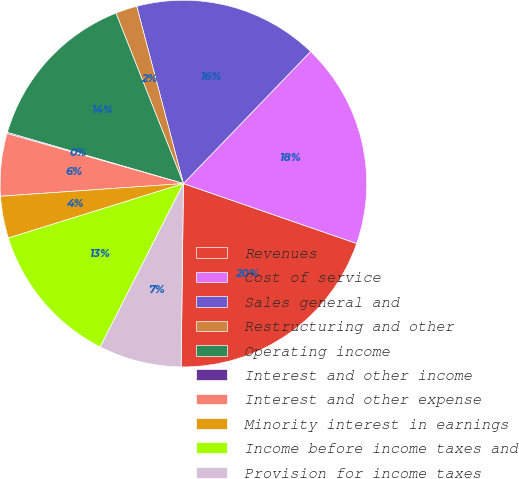<chart> <loc_0><loc_0><loc_500><loc_500><pie_chart><fcel>Revenues<fcel>Cost of service<fcel>Sales general and<fcel>Restructuring and other<fcel>Operating income<fcel>Interest and other income<fcel>Interest and other expense<fcel>Minority interest in earnings<fcel>Income before income taxes and<fcel>Provision for income taxes<nl><fcel>19.9%<fcel>18.1%<fcel>16.3%<fcel>1.9%<fcel>14.5%<fcel>0.1%<fcel>5.5%<fcel>3.7%<fcel>12.7%<fcel>7.3%<nl></chart> 